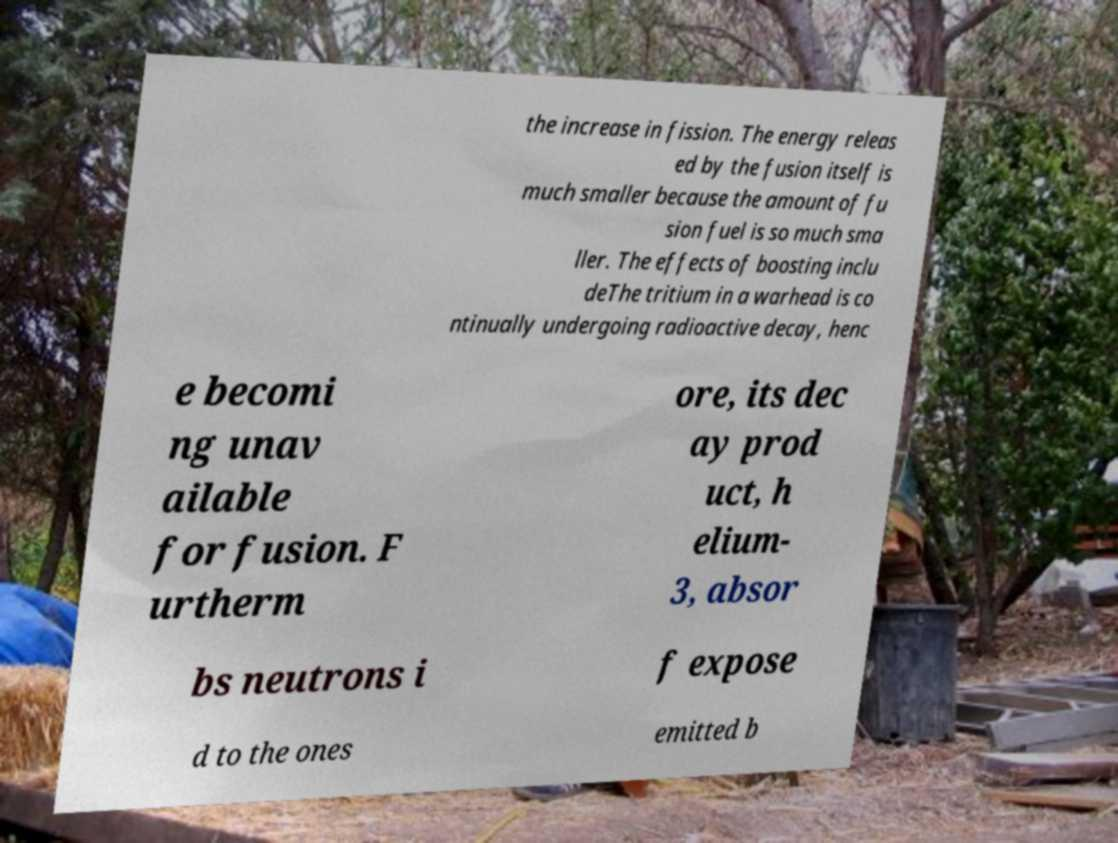Please read and relay the text visible in this image. What does it say? the increase in fission. The energy releas ed by the fusion itself is much smaller because the amount of fu sion fuel is so much sma ller. The effects of boosting inclu deThe tritium in a warhead is co ntinually undergoing radioactive decay, henc e becomi ng unav ailable for fusion. F urtherm ore, its dec ay prod uct, h elium- 3, absor bs neutrons i f expose d to the ones emitted b 